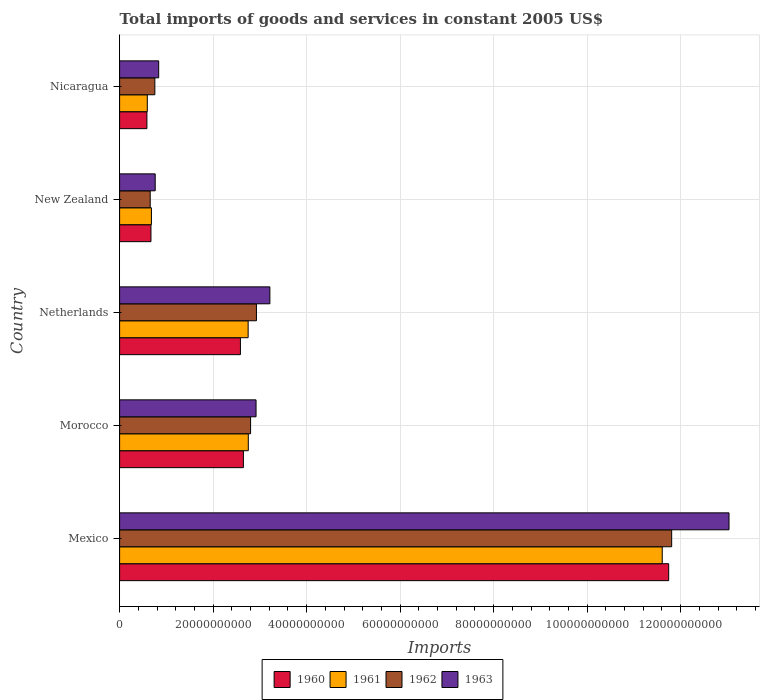Are the number of bars per tick equal to the number of legend labels?
Make the answer very short. Yes. Are the number of bars on each tick of the Y-axis equal?
Your response must be concise. Yes. What is the label of the 1st group of bars from the top?
Make the answer very short. Nicaragua. What is the total imports of goods and services in 1963 in Mexico?
Your answer should be compact. 1.30e+11. Across all countries, what is the maximum total imports of goods and services in 1960?
Keep it short and to the point. 1.17e+11. Across all countries, what is the minimum total imports of goods and services in 1963?
Keep it short and to the point. 7.62e+09. In which country was the total imports of goods and services in 1960 maximum?
Provide a succinct answer. Mexico. In which country was the total imports of goods and services in 1960 minimum?
Ensure brevity in your answer.  Nicaragua. What is the total total imports of goods and services in 1962 in the graph?
Ensure brevity in your answer.  1.89e+11. What is the difference between the total imports of goods and services in 1961 in Mexico and that in Nicaragua?
Your answer should be very brief. 1.10e+11. What is the difference between the total imports of goods and services in 1961 in Nicaragua and the total imports of goods and services in 1960 in Netherlands?
Provide a short and direct response. -1.99e+1. What is the average total imports of goods and services in 1961 per country?
Offer a terse response. 3.68e+1. What is the difference between the total imports of goods and services in 1961 and total imports of goods and services in 1960 in Nicaragua?
Provide a short and direct response. 8.34e+07. What is the ratio of the total imports of goods and services in 1961 in Morocco to that in New Zealand?
Make the answer very short. 4.05. What is the difference between the highest and the second highest total imports of goods and services in 1963?
Keep it short and to the point. 9.82e+1. What is the difference between the highest and the lowest total imports of goods and services in 1963?
Your answer should be very brief. 1.23e+11. Is the sum of the total imports of goods and services in 1961 in Netherlands and New Zealand greater than the maximum total imports of goods and services in 1960 across all countries?
Provide a short and direct response. No. Is it the case that in every country, the sum of the total imports of goods and services in 1960 and total imports of goods and services in 1961 is greater than the sum of total imports of goods and services in 1962 and total imports of goods and services in 1963?
Give a very brief answer. No. Is it the case that in every country, the sum of the total imports of goods and services in 1960 and total imports of goods and services in 1961 is greater than the total imports of goods and services in 1963?
Ensure brevity in your answer.  Yes. How many countries are there in the graph?
Offer a terse response. 5. Does the graph contain any zero values?
Offer a very short reply. No. Does the graph contain grids?
Keep it short and to the point. Yes. Where does the legend appear in the graph?
Your answer should be compact. Bottom center. What is the title of the graph?
Offer a terse response. Total imports of goods and services in constant 2005 US$. Does "1973" appear as one of the legend labels in the graph?
Keep it short and to the point. No. What is the label or title of the X-axis?
Make the answer very short. Imports. What is the Imports of 1960 in Mexico?
Keep it short and to the point. 1.17e+11. What is the Imports of 1961 in Mexico?
Your response must be concise. 1.16e+11. What is the Imports in 1962 in Mexico?
Make the answer very short. 1.18e+11. What is the Imports in 1963 in Mexico?
Your answer should be very brief. 1.30e+11. What is the Imports in 1960 in Morocco?
Make the answer very short. 2.65e+1. What is the Imports in 1961 in Morocco?
Offer a terse response. 2.75e+1. What is the Imports in 1962 in Morocco?
Your response must be concise. 2.80e+1. What is the Imports in 1963 in Morocco?
Provide a short and direct response. 2.92e+1. What is the Imports of 1960 in Netherlands?
Provide a short and direct response. 2.58e+1. What is the Imports of 1961 in Netherlands?
Your answer should be very brief. 2.75e+1. What is the Imports of 1962 in Netherlands?
Keep it short and to the point. 2.93e+1. What is the Imports in 1963 in Netherlands?
Give a very brief answer. 3.21e+1. What is the Imports in 1960 in New Zealand?
Ensure brevity in your answer.  6.71e+09. What is the Imports in 1961 in New Zealand?
Offer a terse response. 6.81e+09. What is the Imports of 1962 in New Zealand?
Keep it short and to the point. 6.55e+09. What is the Imports of 1963 in New Zealand?
Keep it short and to the point. 7.62e+09. What is the Imports in 1960 in Nicaragua?
Provide a short and direct response. 5.84e+09. What is the Imports of 1961 in Nicaragua?
Provide a succinct answer. 5.92e+09. What is the Imports in 1962 in Nicaragua?
Keep it short and to the point. 7.54e+09. What is the Imports in 1963 in Nicaragua?
Offer a very short reply. 8.36e+09. Across all countries, what is the maximum Imports of 1960?
Provide a short and direct response. 1.17e+11. Across all countries, what is the maximum Imports of 1961?
Give a very brief answer. 1.16e+11. Across all countries, what is the maximum Imports in 1962?
Provide a short and direct response. 1.18e+11. Across all countries, what is the maximum Imports in 1963?
Your answer should be very brief. 1.30e+11. Across all countries, what is the minimum Imports in 1960?
Offer a very short reply. 5.84e+09. Across all countries, what is the minimum Imports of 1961?
Provide a succinct answer. 5.92e+09. Across all countries, what is the minimum Imports in 1962?
Give a very brief answer. 6.55e+09. Across all countries, what is the minimum Imports of 1963?
Your response must be concise. 7.62e+09. What is the total Imports of 1960 in the graph?
Ensure brevity in your answer.  1.82e+11. What is the total Imports in 1961 in the graph?
Offer a terse response. 1.84e+11. What is the total Imports in 1962 in the graph?
Offer a terse response. 1.89e+11. What is the total Imports in 1963 in the graph?
Keep it short and to the point. 2.08e+11. What is the difference between the Imports of 1960 in Mexico and that in Morocco?
Give a very brief answer. 9.10e+1. What is the difference between the Imports in 1961 in Mexico and that in Morocco?
Your answer should be compact. 8.85e+1. What is the difference between the Imports in 1962 in Mexico and that in Morocco?
Your answer should be very brief. 9.01e+1. What is the difference between the Imports in 1963 in Mexico and that in Morocco?
Your response must be concise. 1.01e+11. What is the difference between the Imports in 1960 in Mexico and that in Netherlands?
Offer a terse response. 9.16e+1. What is the difference between the Imports in 1961 in Mexico and that in Netherlands?
Provide a short and direct response. 8.86e+1. What is the difference between the Imports of 1962 in Mexico and that in Netherlands?
Ensure brevity in your answer.  8.88e+1. What is the difference between the Imports in 1963 in Mexico and that in Netherlands?
Your response must be concise. 9.82e+1. What is the difference between the Imports in 1960 in Mexico and that in New Zealand?
Offer a terse response. 1.11e+11. What is the difference between the Imports in 1961 in Mexico and that in New Zealand?
Your answer should be compact. 1.09e+11. What is the difference between the Imports in 1962 in Mexico and that in New Zealand?
Ensure brevity in your answer.  1.12e+11. What is the difference between the Imports in 1963 in Mexico and that in New Zealand?
Ensure brevity in your answer.  1.23e+11. What is the difference between the Imports in 1960 in Mexico and that in Nicaragua?
Offer a very short reply. 1.12e+11. What is the difference between the Imports of 1961 in Mexico and that in Nicaragua?
Your answer should be very brief. 1.10e+11. What is the difference between the Imports of 1962 in Mexico and that in Nicaragua?
Provide a succinct answer. 1.11e+11. What is the difference between the Imports in 1963 in Mexico and that in Nicaragua?
Provide a short and direct response. 1.22e+11. What is the difference between the Imports in 1960 in Morocco and that in Netherlands?
Keep it short and to the point. 6.37e+08. What is the difference between the Imports of 1961 in Morocco and that in Netherlands?
Keep it short and to the point. 3.12e+07. What is the difference between the Imports in 1962 in Morocco and that in Netherlands?
Keep it short and to the point. -1.25e+09. What is the difference between the Imports of 1963 in Morocco and that in Netherlands?
Offer a terse response. -2.96e+09. What is the difference between the Imports in 1960 in Morocco and that in New Zealand?
Provide a short and direct response. 1.98e+1. What is the difference between the Imports of 1961 in Morocco and that in New Zealand?
Offer a very short reply. 2.07e+1. What is the difference between the Imports of 1962 in Morocco and that in New Zealand?
Your answer should be compact. 2.15e+1. What is the difference between the Imports in 1963 in Morocco and that in New Zealand?
Make the answer very short. 2.16e+1. What is the difference between the Imports of 1960 in Morocco and that in Nicaragua?
Your answer should be compact. 2.06e+1. What is the difference between the Imports in 1961 in Morocco and that in Nicaragua?
Keep it short and to the point. 2.16e+1. What is the difference between the Imports in 1962 in Morocco and that in Nicaragua?
Offer a very short reply. 2.05e+1. What is the difference between the Imports in 1963 in Morocco and that in Nicaragua?
Your answer should be very brief. 2.08e+1. What is the difference between the Imports in 1960 in Netherlands and that in New Zealand?
Provide a succinct answer. 1.91e+1. What is the difference between the Imports in 1961 in Netherlands and that in New Zealand?
Your response must be concise. 2.07e+1. What is the difference between the Imports of 1962 in Netherlands and that in New Zealand?
Make the answer very short. 2.27e+1. What is the difference between the Imports of 1963 in Netherlands and that in New Zealand?
Your answer should be very brief. 2.45e+1. What is the difference between the Imports of 1960 in Netherlands and that in Nicaragua?
Provide a short and direct response. 2.00e+1. What is the difference between the Imports of 1961 in Netherlands and that in Nicaragua?
Keep it short and to the point. 2.16e+1. What is the difference between the Imports of 1962 in Netherlands and that in Nicaragua?
Offer a terse response. 2.17e+1. What is the difference between the Imports of 1963 in Netherlands and that in Nicaragua?
Your answer should be compact. 2.38e+1. What is the difference between the Imports of 1960 in New Zealand and that in Nicaragua?
Offer a terse response. 8.66e+08. What is the difference between the Imports of 1961 in New Zealand and that in Nicaragua?
Provide a succinct answer. 8.81e+08. What is the difference between the Imports in 1962 in New Zealand and that in Nicaragua?
Your answer should be very brief. -9.91e+08. What is the difference between the Imports in 1963 in New Zealand and that in Nicaragua?
Offer a very short reply. -7.46e+08. What is the difference between the Imports in 1960 in Mexico and the Imports in 1961 in Morocco?
Provide a succinct answer. 8.99e+1. What is the difference between the Imports of 1960 in Mexico and the Imports of 1962 in Morocco?
Offer a very short reply. 8.94e+1. What is the difference between the Imports in 1960 in Mexico and the Imports in 1963 in Morocco?
Offer a very short reply. 8.83e+1. What is the difference between the Imports in 1961 in Mexico and the Imports in 1962 in Morocco?
Your answer should be compact. 8.81e+1. What is the difference between the Imports of 1961 in Mexico and the Imports of 1963 in Morocco?
Your answer should be very brief. 8.69e+1. What is the difference between the Imports in 1962 in Mexico and the Imports in 1963 in Morocco?
Ensure brevity in your answer.  8.89e+1. What is the difference between the Imports in 1960 in Mexico and the Imports in 1961 in Netherlands?
Provide a short and direct response. 9.00e+1. What is the difference between the Imports in 1960 in Mexico and the Imports in 1962 in Netherlands?
Provide a short and direct response. 8.82e+1. What is the difference between the Imports in 1960 in Mexico and the Imports in 1963 in Netherlands?
Offer a terse response. 8.53e+1. What is the difference between the Imports in 1961 in Mexico and the Imports in 1962 in Netherlands?
Give a very brief answer. 8.68e+1. What is the difference between the Imports in 1961 in Mexico and the Imports in 1963 in Netherlands?
Your response must be concise. 8.39e+1. What is the difference between the Imports in 1962 in Mexico and the Imports in 1963 in Netherlands?
Provide a short and direct response. 8.59e+1. What is the difference between the Imports of 1960 in Mexico and the Imports of 1961 in New Zealand?
Your answer should be very brief. 1.11e+11. What is the difference between the Imports in 1960 in Mexico and the Imports in 1962 in New Zealand?
Provide a short and direct response. 1.11e+11. What is the difference between the Imports in 1960 in Mexico and the Imports in 1963 in New Zealand?
Provide a succinct answer. 1.10e+11. What is the difference between the Imports in 1961 in Mexico and the Imports in 1962 in New Zealand?
Your answer should be very brief. 1.10e+11. What is the difference between the Imports of 1961 in Mexico and the Imports of 1963 in New Zealand?
Make the answer very short. 1.08e+11. What is the difference between the Imports in 1962 in Mexico and the Imports in 1963 in New Zealand?
Offer a terse response. 1.10e+11. What is the difference between the Imports of 1960 in Mexico and the Imports of 1961 in Nicaragua?
Provide a succinct answer. 1.12e+11. What is the difference between the Imports of 1960 in Mexico and the Imports of 1962 in Nicaragua?
Your answer should be compact. 1.10e+11. What is the difference between the Imports in 1960 in Mexico and the Imports in 1963 in Nicaragua?
Offer a terse response. 1.09e+11. What is the difference between the Imports of 1961 in Mexico and the Imports of 1962 in Nicaragua?
Your answer should be compact. 1.09e+11. What is the difference between the Imports in 1961 in Mexico and the Imports in 1963 in Nicaragua?
Ensure brevity in your answer.  1.08e+11. What is the difference between the Imports of 1962 in Mexico and the Imports of 1963 in Nicaragua?
Your answer should be very brief. 1.10e+11. What is the difference between the Imports in 1960 in Morocco and the Imports in 1961 in Netherlands?
Offer a terse response. -1.02e+09. What is the difference between the Imports in 1960 in Morocco and the Imports in 1962 in Netherlands?
Your response must be concise. -2.79e+09. What is the difference between the Imports of 1960 in Morocco and the Imports of 1963 in Netherlands?
Provide a succinct answer. -5.66e+09. What is the difference between the Imports in 1961 in Morocco and the Imports in 1962 in Netherlands?
Ensure brevity in your answer.  -1.74e+09. What is the difference between the Imports in 1961 in Morocco and the Imports in 1963 in Netherlands?
Make the answer very short. -4.62e+09. What is the difference between the Imports in 1962 in Morocco and the Imports in 1963 in Netherlands?
Your answer should be compact. -4.13e+09. What is the difference between the Imports of 1960 in Morocco and the Imports of 1961 in New Zealand?
Provide a short and direct response. 1.97e+1. What is the difference between the Imports of 1960 in Morocco and the Imports of 1962 in New Zealand?
Offer a very short reply. 1.99e+1. What is the difference between the Imports in 1960 in Morocco and the Imports in 1963 in New Zealand?
Make the answer very short. 1.89e+1. What is the difference between the Imports in 1961 in Morocco and the Imports in 1962 in New Zealand?
Provide a succinct answer. 2.10e+1. What is the difference between the Imports in 1961 in Morocco and the Imports in 1963 in New Zealand?
Your answer should be compact. 1.99e+1. What is the difference between the Imports of 1962 in Morocco and the Imports of 1963 in New Zealand?
Your answer should be compact. 2.04e+1. What is the difference between the Imports in 1960 in Morocco and the Imports in 1961 in Nicaragua?
Your answer should be compact. 2.06e+1. What is the difference between the Imports of 1960 in Morocco and the Imports of 1962 in Nicaragua?
Provide a short and direct response. 1.89e+1. What is the difference between the Imports of 1960 in Morocco and the Imports of 1963 in Nicaragua?
Provide a short and direct response. 1.81e+1. What is the difference between the Imports in 1961 in Morocco and the Imports in 1962 in Nicaragua?
Give a very brief answer. 2.00e+1. What is the difference between the Imports of 1961 in Morocco and the Imports of 1963 in Nicaragua?
Your response must be concise. 1.92e+1. What is the difference between the Imports in 1962 in Morocco and the Imports in 1963 in Nicaragua?
Provide a succinct answer. 1.97e+1. What is the difference between the Imports of 1960 in Netherlands and the Imports of 1961 in New Zealand?
Provide a short and direct response. 1.90e+1. What is the difference between the Imports in 1960 in Netherlands and the Imports in 1962 in New Zealand?
Your answer should be compact. 1.93e+1. What is the difference between the Imports of 1960 in Netherlands and the Imports of 1963 in New Zealand?
Ensure brevity in your answer.  1.82e+1. What is the difference between the Imports of 1961 in Netherlands and the Imports of 1962 in New Zealand?
Offer a very short reply. 2.10e+1. What is the difference between the Imports in 1961 in Netherlands and the Imports in 1963 in New Zealand?
Offer a very short reply. 1.99e+1. What is the difference between the Imports of 1962 in Netherlands and the Imports of 1963 in New Zealand?
Keep it short and to the point. 2.17e+1. What is the difference between the Imports in 1960 in Netherlands and the Imports in 1961 in Nicaragua?
Make the answer very short. 1.99e+1. What is the difference between the Imports of 1960 in Netherlands and the Imports of 1962 in Nicaragua?
Offer a terse response. 1.83e+1. What is the difference between the Imports in 1960 in Netherlands and the Imports in 1963 in Nicaragua?
Offer a terse response. 1.75e+1. What is the difference between the Imports in 1961 in Netherlands and the Imports in 1962 in Nicaragua?
Provide a succinct answer. 2.00e+1. What is the difference between the Imports in 1961 in Netherlands and the Imports in 1963 in Nicaragua?
Your answer should be compact. 1.91e+1. What is the difference between the Imports of 1962 in Netherlands and the Imports of 1963 in Nicaragua?
Make the answer very short. 2.09e+1. What is the difference between the Imports of 1960 in New Zealand and the Imports of 1961 in Nicaragua?
Your answer should be very brief. 7.83e+08. What is the difference between the Imports in 1960 in New Zealand and the Imports in 1962 in Nicaragua?
Give a very brief answer. -8.30e+08. What is the difference between the Imports in 1960 in New Zealand and the Imports in 1963 in Nicaragua?
Offer a terse response. -1.66e+09. What is the difference between the Imports of 1961 in New Zealand and the Imports of 1962 in Nicaragua?
Provide a succinct answer. -7.32e+08. What is the difference between the Imports in 1961 in New Zealand and the Imports in 1963 in Nicaragua?
Your answer should be very brief. -1.56e+09. What is the difference between the Imports in 1962 in New Zealand and the Imports in 1963 in Nicaragua?
Keep it short and to the point. -1.82e+09. What is the average Imports in 1960 per country?
Offer a very short reply. 3.65e+1. What is the average Imports of 1961 per country?
Your response must be concise. 3.68e+1. What is the average Imports in 1962 per country?
Ensure brevity in your answer.  3.79e+1. What is the average Imports in 1963 per country?
Your response must be concise. 4.15e+1. What is the difference between the Imports of 1960 and Imports of 1961 in Mexico?
Offer a very short reply. 1.38e+09. What is the difference between the Imports of 1960 and Imports of 1962 in Mexico?
Your answer should be very brief. -6.38e+08. What is the difference between the Imports in 1960 and Imports in 1963 in Mexico?
Your answer should be compact. -1.29e+1. What is the difference between the Imports in 1961 and Imports in 1962 in Mexico?
Your answer should be compact. -2.02e+09. What is the difference between the Imports in 1961 and Imports in 1963 in Mexico?
Keep it short and to the point. -1.43e+1. What is the difference between the Imports in 1962 and Imports in 1963 in Mexico?
Provide a succinct answer. -1.23e+1. What is the difference between the Imports of 1960 and Imports of 1961 in Morocco?
Your answer should be compact. -1.05e+09. What is the difference between the Imports in 1960 and Imports in 1962 in Morocco?
Offer a terse response. -1.54e+09. What is the difference between the Imports of 1960 and Imports of 1963 in Morocco?
Your answer should be compact. -2.70e+09. What is the difference between the Imports in 1961 and Imports in 1962 in Morocco?
Offer a terse response. -4.88e+08. What is the difference between the Imports in 1961 and Imports in 1963 in Morocco?
Provide a succinct answer. -1.66e+09. What is the difference between the Imports in 1962 and Imports in 1963 in Morocco?
Offer a terse response. -1.17e+09. What is the difference between the Imports in 1960 and Imports in 1961 in Netherlands?
Your answer should be compact. -1.65e+09. What is the difference between the Imports of 1960 and Imports of 1962 in Netherlands?
Provide a short and direct response. -3.43e+09. What is the difference between the Imports of 1960 and Imports of 1963 in Netherlands?
Your response must be concise. -6.30e+09. What is the difference between the Imports of 1961 and Imports of 1962 in Netherlands?
Give a very brief answer. -1.77e+09. What is the difference between the Imports in 1961 and Imports in 1963 in Netherlands?
Offer a terse response. -4.65e+09. What is the difference between the Imports in 1962 and Imports in 1963 in Netherlands?
Your answer should be very brief. -2.87e+09. What is the difference between the Imports in 1960 and Imports in 1961 in New Zealand?
Keep it short and to the point. -9.87e+07. What is the difference between the Imports of 1960 and Imports of 1962 in New Zealand?
Offer a very short reply. 1.61e+08. What is the difference between the Imports in 1960 and Imports in 1963 in New Zealand?
Offer a very short reply. -9.09e+08. What is the difference between the Imports in 1961 and Imports in 1962 in New Zealand?
Give a very brief answer. 2.60e+08. What is the difference between the Imports in 1961 and Imports in 1963 in New Zealand?
Make the answer very short. -8.10e+08. What is the difference between the Imports of 1962 and Imports of 1963 in New Zealand?
Provide a succinct answer. -1.07e+09. What is the difference between the Imports of 1960 and Imports of 1961 in Nicaragua?
Give a very brief answer. -8.34e+07. What is the difference between the Imports in 1960 and Imports in 1962 in Nicaragua?
Offer a terse response. -1.70e+09. What is the difference between the Imports of 1960 and Imports of 1963 in Nicaragua?
Give a very brief answer. -2.52e+09. What is the difference between the Imports of 1961 and Imports of 1962 in Nicaragua?
Ensure brevity in your answer.  -1.61e+09. What is the difference between the Imports in 1961 and Imports in 1963 in Nicaragua?
Offer a terse response. -2.44e+09. What is the difference between the Imports in 1962 and Imports in 1963 in Nicaragua?
Your answer should be very brief. -8.25e+08. What is the ratio of the Imports of 1960 in Mexico to that in Morocco?
Offer a terse response. 4.44. What is the ratio of the Imports of 1961 in Mexico to that in Morocco?
Provide a short and direct response. 4.22. What is the ratio of the Imports of 1962 in Mexico to that in Morocco?
Offer a terse response. 4.22. What is the ratio of the Imports in 1963 in Mexico to that in Morocco?
Keep it short and to the point. 4.47. What is the ratio of the Imports in 1960 in Mexico to that in Netherlands?
Your answer should be very brief. 4.54. What is the ratio of the Imports of 1961 in Mexico to that in Netherlands?
Offer a very short reply. 4.22. What is the ratio of the Imports in 1962 in Mexico to that in Netherlands?
Make the answer very short. 4.03. What is the ratio of the Imports of 1963 in Mexico to that in Netherlands?
Your answer should be very brief. 4.06. What is the ratio of the Imports in 1960 in Mexico to that in New Zealand?
Offer a terse response. 17.51. What is the ratio of the Imports of 1961 in Mexico to that in New Zealand?
Your answer should be very brief. 17.06. What is the ratio of the Imports of 1962 in Mexico to that in New Zealand?
Provide a succinct answer. 18.04. What is the ratio of the Imports of 1963 in Mexico to that in New Zealand?
Provide a short and direct response. 17.12. What is the ratio of the Imports in 1960 in Mexico to that in Nicaragua?
Make the answer very short. 20.11. What is the ratio of the Imports of 1961 in Mexico to that in Nicaragua?
Ensure brevity in your answer.  19.59. What is the ratio of the Imports in 1962 in Mexico to that in Nicaragua?
Offer a terse response. 15.67. What is the ratio of the Imports of 1963 in Mexico to that in Nicaragua?
Your answer should be compact. 15.59. What is the ratio of the Imports in 1960 in Morocco to that in Netherlands?
Give a very brief answer. 1.02. What is the ratio of the Imports in 1961 in Morocco to that in Netherlands?
Make the answer very short. 1. What is the ratio of the Imports in 1962 in Morocco to that in Netherlands?
Your answer should be compact. 0.96. What is the ratio of the Imports of 1963 in Morocco to that in Netherlands?
Provide a succinct answer. 0.91. What is the ratio of the Imports in 1960 in Morocco to that in New Zealand?
Keep it short and to the point. 3.95. What is the ratio of the Imports of 1961 in Morocco to that in New Zealand?
Keep it short and to the point. 4.04. What is the ratio of the Imports of 1962 in Morocco to that in New Zealand?
Your answer should be very brief. 4.28. What is the ratio of the Imports in 1963 in Morocco to that in New Zealand?
Give a very brief answer. 3.83. What is the ratio of the Imports of 1960 in Morocco to that in Nicaragua?
Offer a terse response. 4.53. What is the ratio of the Imports in 1961 in Morocco to that in Nicaragua?
Provide a succinct answer. 4.65. What is the ratio of the Imports in 1962 in Morocco to that in Nicaragua?
Give a very brief answer. 3.72. What is the ratio of the Imports in 1963 in Morocco to that in Nicaragua?
Offer a very short reply. 3.49. What is the ratio of the Imports of 1960 in Netherlands to that in New Zealand?
Keep it short and to the point. 3.85. What is the ratio of the Imports of 1961 in Netherlands to that in New Zealand?
Make the answer very short. 4.04. What is the ratio of the Imports of 1962 in Netherlands to that in New Zealand?
Give a very brief answer. 4.47. What is the ratio of the Imports in 1963 in Netherlands to that in New Zealand?
Keep it short and to the point. 4.22. What is the ratio of the Imports in 1960 in Netherlands to that in Nicaragua?
Your answer should be compact. 4.42. What is the ratio of the Imports in 1961 in Netherlands to that in Nicaragua?
Your answer should be compact. 4.64. What is the ratio of the Imports of 1962 in Netherlands to that in Nicaragua?
Keep it short and to the point. 3.88. What is the ratio of the Imports in 1963 in Netherlands to that in Nicaragua?
Your answer should be compact. 3.84. What is the ratio of the Imports of 1960 in New Zealand to that in Nicaragua?
Your response must be concise. 1.15. What is the ratio of the Imports in 1961 in New Zealand to that in Nicaragua?
Provide a succinct answer. 1.15. What is the ratio of the Imports in 1962 in New Zealand to that in Nicaragua?
Ensure brevity in your answer.  0.87. What is the ratio of the Imports of 1963 in New Zealand to that in Nicaragua?
Make the answer very short. 0.91. What is the difference between the highest and the second highest Imports in 1960?
Offer a very short reply. 9.10e+1. What is the difference between the highest and the second highest Imports in 1961?
Keep it short and to the point. 8.85e+1. What is the difference between the highest and the second highest Imports of 1962?
Your answer should be very brief. 8.88e+1. What is the difference between the highest and the second highest Imports of 1963?
Provide a short and direct response. 9.82e+1. What is the difference between the highest and the lowest Imports of 1960?
Provide a succinct answer. 1.12e+11. What is the difference between the highest and the lowest Imports of 1961?
Give a very brief answer. 1.10e+11. What is the difference between the highest and the lowest Imports of 1962?
Ensure brevity in your answer.  1.12e+11. What is the difference between the highest and the lowest Imports in 1963?
Keep it short and to the point. 1.23e+11. 